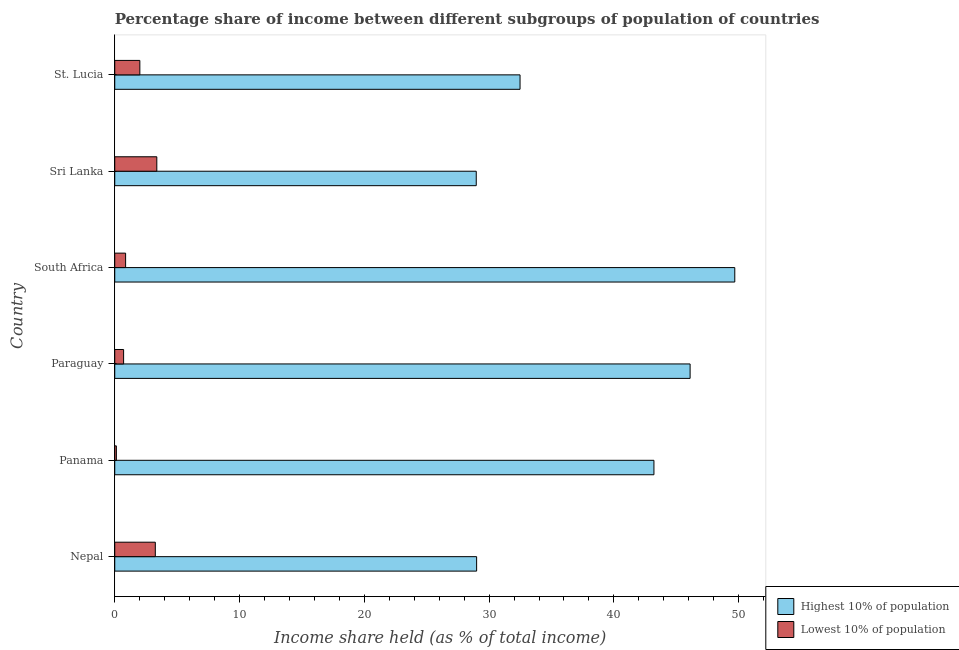How many groups of bars are there?
Make the answer very short. 6. Are the number of bars per tick equal to the number of legend labels?
Provide a succinct answer. Yes. How many bars are there on the 5th tick from the top?
Provide a succinct answer. 2. What is the label of the 1st group of bars from the top?
Offer a very short reply. St. Lucia. In how many cases, is the number of bars for a given country not equal to the number of legend labels?
Ensure brevity in your answer.  0. Across all countries, what is the maximum income share held by highest 10% of the population?
Provide a succinct answer. 49.69. Across all countries, what is the minimum income share held by lowest 10% of the population?
Keep it short and to the point. 0.13. In which country was the income share held by lowest 10% of the population maximum?
Give a very brief answer. Sri Lanka. In which country was the income share held by highest 10% of the population minimum?
Make the answer very short. Sri Lanka. What is the total income share held by lowest 10% of the population in the graph?
Your answer should be compact. 10.34. What is the difference between the income share held by highest 10% of the population in Paraguay and that in South Africa?
Your answer should be very brief. -3.58. What is the difference between the income share held by lowest 10% of the population in St. Lucia and the income share held by highest 10% of the population in Sri Lanka?
Your response must be concise. -26.96. What is the average income share held by highest 10% of the population per country?
Your answer should be compact. 38.24. What is the difference between the income share held by lowest 10% of the population and income share held by highest 10% of the population in Paraguay?
Make the answer very short. -45.4. In how many countries, is the income share held by lowest 10% of the population greater than 12 %?
Ensure brevity in your answer.  0. What is the ratio of the income share held by highest 10% of the population in Sri Lanka to that in St. Lucia?
Keep it short and to the point. 0.89. Is the difference between the income share held by lowest 10% of the population in Panama and South Africa greater than the difference between the income share held by highest 10% of the population in Panama and South Africa?
Give a very brief answer. Yes. What is the difference between the highest and the second highest income share held by lowest 10% of the population?
Give a very brief answer. 0.12. What is the difference between the highest and the lowest income share held by lowest 10% of the population?
Your response must be concise. 3.24. What does the 2nd bar from the top in Paraguay represents?
Offer a very short reply. Highest 10% of population. What does the 2nd bar from the bottom in Paraguay represents?
Keep it short and to the point. Lowest 10% of population. How many bars are there?
Make the answer very short. 12. Are all the bars in the graph horizontal?
Provide a short and direct response. Yes. How many countries are there in the graph?
Make the answer very short. 6. What is the difference between two consecutive major ticks on the X-axis?
Offer a terse response. 10. Does the graph contain grids?
Offer a terse response. No. How many legend labels are there?
Give a very brief answer. 2. What is the title of the graph?
Give a very brief answer. Percentage share of income between different subgroups of population of countries. Does "Nitrous oxide emissions" appear as one of the legend labels in the graph?
Your response must be concise. No. What is the label or title of the X-axis?
Give a very brief answer. Income share held (as % of total income). What is the label or title of the Y-axis?
Provide a succinct answer. Country. What is the Income share held (as % of total income) of Highest 10% of population in Nepal?
Make the answer very short. 29. What is the Income share held (as % of total income) in Highest 10% of population in Panama?
Ensure brevity in your answer.  43.21. What is the Income share held (as % of total income) of Lowest 10% of population in Panama?
Ensure brevity in your answer.  0.13. What is the Income share held (as % of total income) in Highest 10% of population in Paraguay?
Make the answer very short. 46.11. What is the Income share held (as % of total income) of Lowest 10% of population in Paraguay?
Give a very brief answer. 0.71. What is the Income share held (as % of total income) of Highest 10% of population in South Africa?
Provide a short and direct response. 49.69. What is the Income share held (as % of total income) in Lowest 10% of population in South Africa?
Your answer should be very brief. 0.87. What is the Income share held (as % of total income) in Highest 10% of population in Sri Lanka?
Provide a succinct answer. 28.97. What is the Income share held (as % of total income) of Lowest 10% of population in Sri Lanka?
Give a very brief answer. 3.37. What is the Income share held (as % of total income) in Highest 10% of population in St. Lucia?
Keep it short and to the point. 32.48. What is the Income share held (as % of total income) in Lowest 10% of population in St. Lucia?
Provide a succinct answer. 2.01. Across all countries, what is the maximum Income share held (as % of total income) of Highest 10% of population?
Your answer should be compact. 49.69. Across all countries, what is the maximum Income share held (as % of total income) in Lowest 10% of population?
Give a very brief answer. 3.37. Across all countries, what is the minimum Income share held (as % of total income) of Highest 10% of population?
Keep it short and to the point. 28.97. Across all countries, what is the minimum Income share held (as % of total income) of Lowest 10% of population?
Ensure brevity in your answer.  0.13. What is the total Income share held (as % of total income) of Highest 10% of population in the graph?
Provide a short and direct response. 229.46. What is the total Income share held (as % of total income) in Lowest 10% of population in the graph?
Offer a terse response. 10.34. What is the difference between the Income share held (as % of total income) in Highest 10% of population in Nepal and that in Panama?
Offer a very short reply. -14.21. What is the difference between the Income share held (as % of total income) in Lowest 10% of population in Nepal and that in Panama?
Your answer should be compact. 3.12. What is the difference between the Income share held (as % of total income) of Highest 10% of population in Nepal and that in Paraguay?
Ensure brevity in your answer.  -17.11. What is the difference between the Income share held (as % of total income) of Lowest 10% of population in Nepal and that in Paraguay?
Give a very brief answer. 2.54. What is the difference between the Income share held (as % of total income) of Highest 10% of population in Nepal and that in South Africa?
Keep it short and to the point. -20.69. What is the difference between the Income share held (as % of total income) in Lowest 10% of population in Nepal and that in South Africa?
Provide a short and direct response. 2.38. What is the difference between the Income share held (as % of total income) of Lowest 10% of population in Nepal and that in Sri Lanka?
Give a very brief answer. -0.12. What is the difference between the Income share held (as % of total income) in Highest 10% of population in Nepal and that in St. Lucia?
Make the answer very short. -3.48. What is the difference between the Income share held (as % of total income) in Lowest 10% of population in Nepal and that in St. Lucia?
Ensure brevity in your answer.  1.24. What is the difference between the Income share held (as % of total income) of Lowest 10% of population in Panama and that in Paraguay?
Your answer should be compact. -0.58. What is the difference between the Income share held (as % of total income) of Highest 10% of population in Panama and that in South Africa?
Your response must be concise. -6.48. What is the difference between the Income share held (as % of total income) in Lowest 10% of population in Panama and that in South Africa?
Offer a terse response. -0.74. What is the difference between the Income share held (as % of total income) in Highest 10% of population in Panama and that in Sri Lanka?
Offer a very short reply. 14.24. What is the difference between the Income share held (as % of total income) in Lowest 10% of population in Panama and that in Sri Lanka?
Offer a terse response. -3.24. What is the difference between the Income share held (as % of total income) of Highest 10% of population in Panama and that in St. Lucia?
Keep it short and to the point. 10.73. What is the difference between the Income share held (as % of total income) in Lowest 10% of population in Panama and that in St. Lucia?
Your answer should be very brief. -1.88. What is the difference between the Income share held (as % of total income) of Highest 10% of population in Paraguay and that in South Africa?
Keep it short and to the point. -3.58. What is the difference between the Income share held (as % of total income) in Lowest 10% of population in Paraguay and that in South Africa?
Keep it short and to the point. -0.16. What is the difference between the Income share held (as % of total income) in Highest 10% of population in Paraguay and that in Sri Lanka?
Keep it short and to the point. 17.14. What is the difference between the Income share held (as % of total income) of Lowest 10% of population in Paraguay and that in Sri Lanka?
Ensure brevity in your answer.  -2.66. What is the difference between the Income share held (as % of total income) of Highest 10% of population in Paraguay and that in St. Lucia?
Your answer should be very brief. 13.63. What is the difference between the Income share held (as % of total income) in Lowest 10% of population in Paraguay and that in St. Lucia?
Offer a very short reply. -1.3. What is the difference between the Income share held (as % of total income) in Highest 10% of population in South Africa and that in Sri Lanka?
Your response must be concise. 20.72. What is the difference between the Income share held (as % of total income) in Lowest 10% of population in South Africa and that in Sri Lanka?
Your answer should be compact. -2.5. What is the difference between the Income share held (as % of total income) in Highest 10% of population in South Africa and that in St. Lucia?
Offer a very short reply. 17.21. What is the difference between the Income share held (as % of total income) in Lowest 10% of population in South Africa and that in St. Lucia?
Offer a terse response. -1.14. What is the difference between the Income share held (as % of total income) in Highest 10% of population in Sri Lanka and that in St. Lucia?
Provide a short and direct response. -3.51. What is the difference between the Income share held (as % of total income) of Lowest 10% of population in Sri Lanka and that in St. Lucia?
Give a very brief answer. 1.36. What is the difference between the Income share held (as % of total income) of Highest 10% of population in Nepal and the Income share held (as % of total income) of Lowest 10% of population in Panama?
Keep it short and to the point. 28.87. What is the difference between the Income share held (as % of total income) of Highest 10% of population in Nepal and the Income share held (as % of total income) of Lowest 10% of population in Paraguay?
Your response must be concise. 28.29. What is the difference between the Income share held (as % of total income) of Highest 10% of population in Nepal and the Income share held (as % of total income) of Lowest 10% of population in South Africa?
Provide a succinct answer. 28.13. What is the difference between the Income share held (as % of total income) of Highest 10% of population in Nepal and the Income share held (as % of total income) of Lowest 10% of population in Sri Lanka?
Keep it short and to the point. 25.63. What is the difference between the Income share held (as % of total income) in Highest 10% of population in Nepal and the Income share held (as % of total income) in Lowest 10% of population in St. Lucia?
Offer a very short reply. 26.99. What is the difference between the Income share held (as % of total income) in Highest 10% of population in Panama and the Income share held (as % of total income) in Lowest 10% of population in Paraguay?
Offer a very short reply. 42.5. What is the difference between the Income share held (as % of total income) of Highest 10% of population in Panama and the Income share held (as % of total income) of Lowest 10% of population in South Africa?
Offer a terse response. 42.34. What is the difference between the Income share held (as % of total income) of Highest 10% of population in Panama and the Income share held (as % of total income) of Lowest 10% of population in Sri Lanka?
Your answer should be compact. 39.84. What is the difference between the Income share held (as % of total income) in Highest 10% of population in Panama and the Income share held (as % of total income) in Lowest 10% of population in St. Lucia?
Make the answer very short. 41.2. What is the difference between the Income share held (as % of total income) in Highest 10% of population in Paraguay and the Income share held (as % of total income) in Lowest 10% of population in South Africa?
Keep it short and to the point. 45.24. What is the difference between the Income share held (as % of total income) in Highest 10% of population in Paraguay and the Income share held (as % of total income) in Lowest 10% of population in Sri Lanka?
Give a very brief answer. 42.74. What is the difference between the Income share held (as % of total income) in Highest 10% of population in Paraguay and the Income share held (as % of total income) in Lowest 10% of population in St. Lucia?
Provide a short and direct response. 44.1. What is the difference between the Income share held (as % of total income) in Highest 10% of population in South Africa and the Income share held (as % of total income) in Lowest 10% of population in Sri Lanka?
Your answer should be compact. 46.32. What is the difference between the Income share held (as % of total income) of Highest 10% of population in South Africa and the Income share held (as % of total income) of Lowest 10% of population in St. Lucia?
Your answer should be compact. 47.68. What is the difference between the Income share held (as % of total income) in Highest 10% of population in Sri Lanka and the Income share held (as % of total income) in Lowest 10% of population in St. Lucia?
Make the answer very short. 26.96. What is the average Income share held (as % of total income) of Highest 10% of population per country?
Make the answer very short. 38.24. What is the average Income share held (as % of total income) in Lowest 10% of population per country?
Your answer should be very brief. 1.72. What is the difference between the Income share held (as % of total income) in Highest 10% of population and Income share held (as % of total income) in Lowest 10% of population in Nepal?
Keep it short and to the point. 25.75. What is the difference between the Income share held (as % of total income) of Highest 10% of population and Income share held (as % of total income) of Lowest 10% of population in Panama?
Provide a succinct answer. 43.08. What is the difference between the Income share held (as % of total income) of Highest 10% of population and Income share held (as % of total income) of Lowest 10% of population in Paraguay?
Make the answer very short. 45.4. What is the difference between the Income share held (as % of total income) in Highest 10% of population and Income share held (as % of total income) in Lowest 10% of population in South Africa?
Give a very brief answer. 48.82. What is the difference between the Income share held (as % of total income) in Highest 10% of population and Income share held (as % of total income) in Lowest 10% of population in Sri Lanka?
Offer a terse response. 25.6. What is the difference between the Income share held (as % of total income) in Highest 10% of population and Income share held (as % of total income) in Lowest 10% of population in St. Lucia?
Keep it short and to the point. 30.47. What is the ratio of the Income share held (as % of total income) in Highest 10% of population in Nepal to that in Panama?
Make the answer very short. 0.67. What is the ratio of the Income share held (as % of total income) in Highest 10% of population in Nepal to that in Paraguay?
Offer a very short reply. 0.63. What is the ratio of the Income share held (as % of total income) of Lowest 10% of population in Nepal to that in Paraguay?
Give a very brief answer. 4.58. What is the ratio of the Income share held (as % of total income) in Highest 10% of population in Nepal to that in South Africa?
Provide a short and direct response. 0.58. What is the ratio of the Income share held (as % of total income) of Lowest 10% of population in Nepal to that in South Africa?
Your answer should be very brief. 3.74. What is the ratio of the Income share held (as % of total income) in Highest 10% of population in Nepal to that in Sri Lanka?
Your response must be concise. 1. What is the ratio of the Income share held (as % of total income) of Lowest 10% of population in Nepal to that in Sri Lanka?
Offer a very short reply. 0.96. What is the ratio of the Income share held (as % of total income) of Highest 10% of population in Nepal to that in St. Lucia?
Make the answer very short. 0.89. What is the ratio of the Income share held (as % of total income) of Lowest 10% of population in Nepal to that in St. Lucia?
Make the answer very short. 1.62. What is the ratio of the Income share held (as % of total income) of Highest 10% of population in Panama to that in Paraguay?
Provide a short and direct response. 0.94. What is the ratio of the Income share held (as % of total income) in Lowest 10% of population in Panama to that in Paraguay?
Offer a very short reply. 0.18. What is the ratio of the Income share held (as % of total income) of Highest 10% of population in Panama to that in South Africa?
Provide a succinct answer. 0.87. What is the ratio of the Income share held (as % of total income) of Lowest 10% of population in Panama to that in South Africa?
Your answer should be very brief. 0.15. What is the ratio of the Income share held (as % of total income) in Highest 10% of population in Panama to that in Sri Lanka?
Provide a short and direct response. 1.49. What is the ratio of the Income share held (as % of total income) in Lowest 10% of population in Panama to that in Sri Lanka?
Your answer should be compact. 0.04. What is the ratio of the Income share held (as % of total income) of Highest 10% of population in Panama to that in St. Lucia?
Provide a short and direct response. 1.33. What is the ratio of the Income share held (as % of total income) of Lowest 10% of population in Panama to that in St. Lucia?
Provide a succinct answer. 0.06. What is the ratio of the Income share held (as % of total income) of Highest 10% of population in Paraguay to that in South Africa?
Offer a very short reply. 0.93. What is the ratio of the Income share held (as % of total income) of Lowest 10% of population in Paraguay to that in South Africa?
Offer a very short reply. 0.82. What is the ratio of the Income share held (as % of total income) of Highest 10% of population in Paraguay to that in Sri Lanka?
Your response must be concise. 1.59. What is the ratio of the Income share held (as % of total income) of Lowest 10% of population in Paraguay to that in Sri Lanka?
Provide a short and direct response. 0.21. What is the ratio of the Income share held (as % of total income) of Highest 10% of population in Paraguay to that in St. Lucia?
Offer a very short reply. 1.42. What is the ratio of the Income share held (as % of total income) of Lowest 10% of population in Paraguay to that in St. Lucia?
Provide a short and direct response. 0.35. What is the ratio of the Income share held (as % of total income) in Highest 10% of population in South Africa to that in Sri Lanka?
Provide a short and direct response. 1.72. What is the ratio of the Income share held (as % of total income) in Lowest 10% of population in South Africa to that in Sri Lanka?
Provide a succinct answer. 0.26. What is the ratio of the Income share held (as % of total income) of Highest 10% of population in South Africa to that in St. Lucia?
Provide a short and direct response. 1.53. What is the ratio of the Income share held (as % of total income) in Lowest 10% of population in South Africa to that in St. Lucia?
Your answer should be very brief. 0.43. What is the ratio of the Income share held (as % of total income) of Highest 10% of population in Sri Lanka to that in St. Lucia?
Provide a short and direct response. 0.89. What is the ratio of the Income share held (as % of total income) of Lowest 10% of population in Sri Lanka to that in St. Lucia?
Provide a succinct answer. 1.68. What is the difference between the highest and the second highest Income share held (as % of total income) in Highest 10% of population?
Your response must be concise. 3.58. What is the difference between the highest and the second highest Income share held (as % of total income) of Lowest 10% of population?
Offer a terse response. 0.12. What is the difference between the highest and the lowest Income share held (as % of total income) of Highest 10% of population?
Keep it short and to the point. 20.72. What is the difference between the highest and the lowest Income share held (as % of total income) in Lowest 10% of population?
Your answer should be compact. 3.24. 